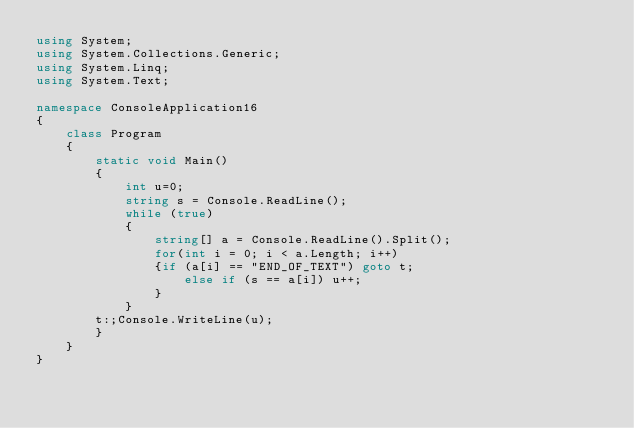Convert code to text. <code><loc_0><loc_0><loc_500><loc_500><_C#_>using System;
using System.Collections.Generic;
using System.Linq;
using System.Text;

namespace ConsoleApplication16
{
    class Program
    {
        static void Main()
        {
            int u=0;
            string s = Console.ReadLine();
            while (true)
            {
                string[] a = Console.ReadLine().Split();
                for(int i = 0; i < a.Length; i++)
                {if (a[i] == "END_OF_TEXT") goto t;
                    else if (s == a[i]) u++;
                }
            }
        t:;Console.WriteLine(u);
        }
    }
}</code> 